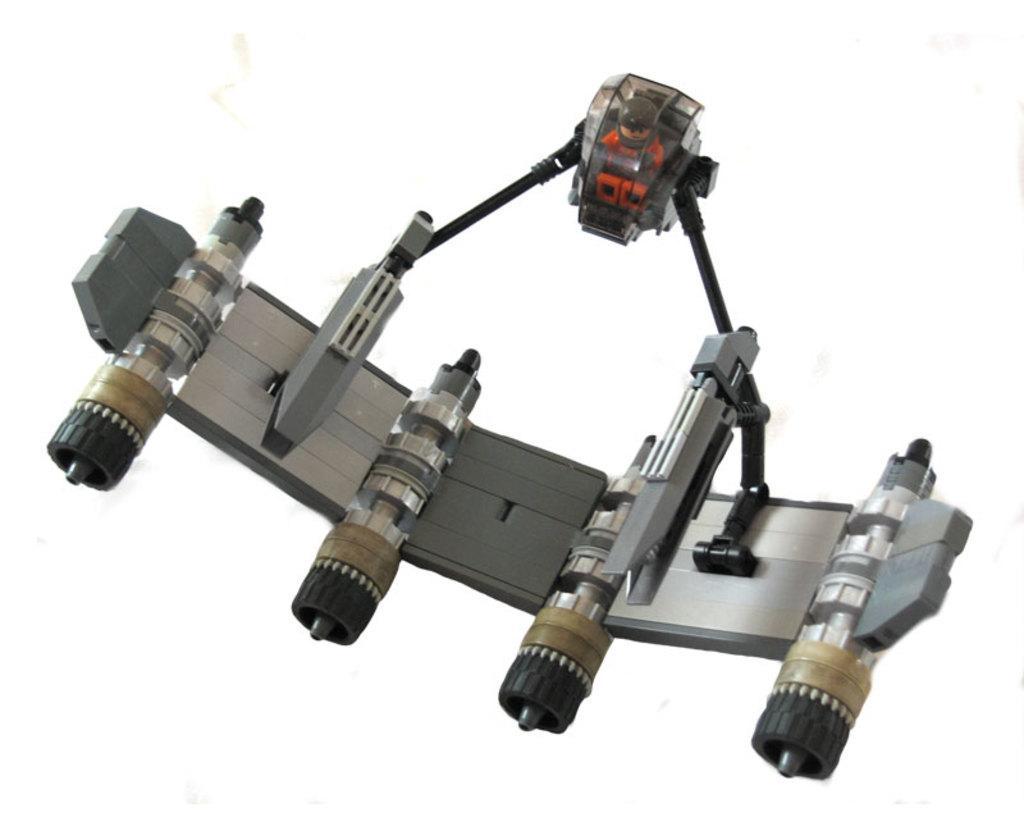Please provide a concise description of this image. There is one object present in the middle of this image and the background is in white. 